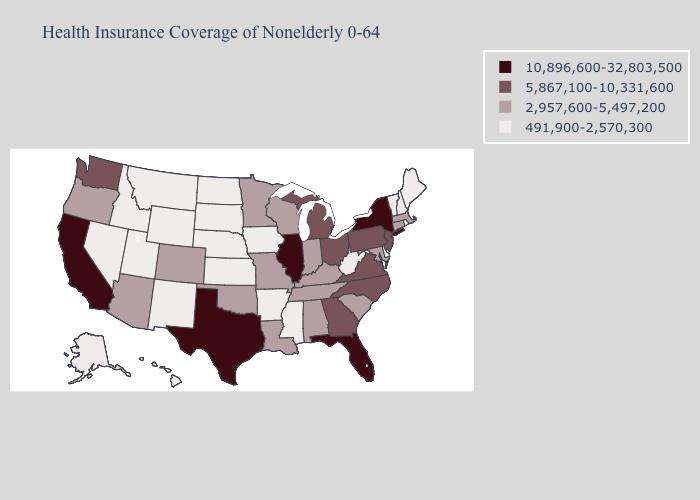Name the states that have a value in the range 10,896,600-32,803,500?
Be succinct. California, Florida, Illinois, New York, Texas. What is the highest value in states that border North Carolina?
Concise answer only. 5,867,100-10,331,600. Does Louisiana have the same value as Maine?
Write a very short answer. No. Is the legend a continuous bar?
Answer briefly. No. Does Delaware have the lowest value in the South?
Answer briefly. Yes. Does Iowa have the lowest value in the MidWest?
Quick response, please. Yes. What is the lowest value in the USA?
Short answer required. 491,900-2,570,300. What is the value of Illinois?
Short answer required. 10,896,600-32,803,500. What is the value of Illinois?
Give a very brief answer. 10,896,600-32,803,500. Name the states that have a value in the range 5,867,100-10,331,600?
Answer briefly. Georgia, Michigan, New Jersey, North Carolina, Ohio, Pennsylvania, Virginia, Washington. What is the lowest value in states that border Florida?
Concise answer only. 2,957,600-5,497,200. Name the states that have a value in the range 491,900-2,570,300?
Write a very short answer. Alaska, Arkansas, Delaware, Hawaii, Idaho, Iowa, Kansas, Maine, Mississippi, Montana, Nebraska, Nevada, New Hampshire, New Mexico, North Dakota, Rhode Island, South Dakota, Utah, Vermont, West Virginia, Wyoming. What is the value of Nevada?
Quick response, please. 491,900-2,570,300. Does the map have missing data?
Be succinct. No. What is the value of Delaware?
Concise answer only. 491,900-2,570,300. 